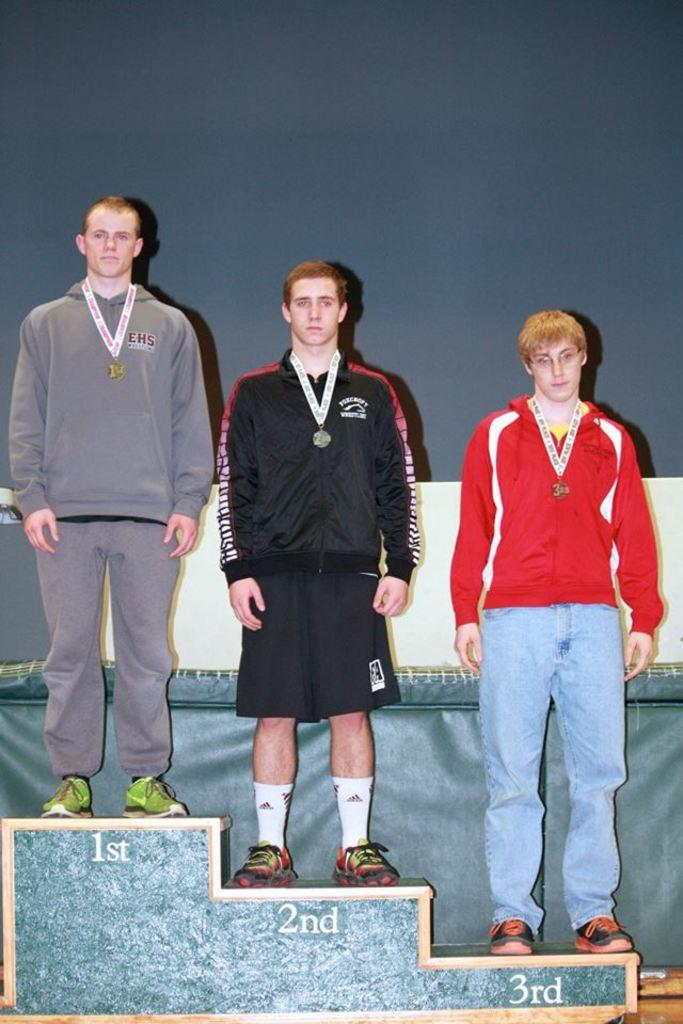How many people are in the center of the image? There are three persons standing in the center of the image. What are the people doing in the image? The three persons are standing on a stool. What can be seen in the background of the image? There is a curtain and a wall in the background of the image. What type of pollution is visible in the image? There is no visible pollution in the image. Is there a birthday celebration happening in the image? There is no indication of a birthday celebration in the image. 